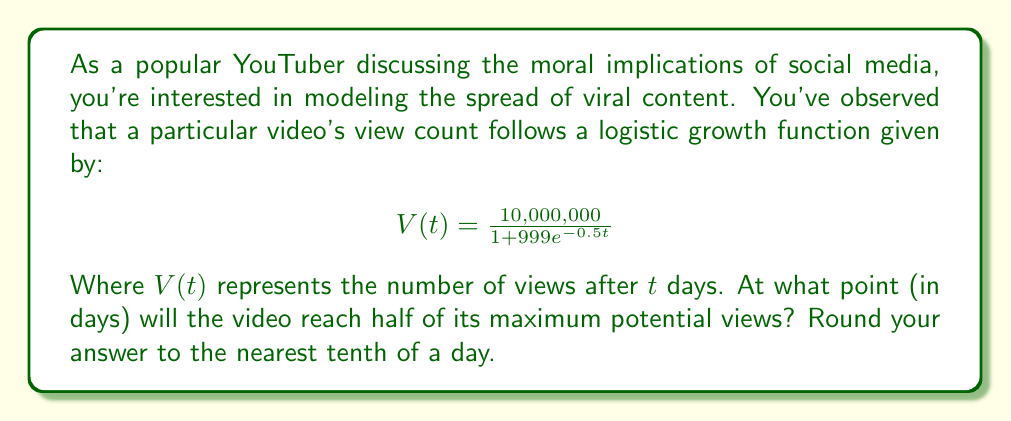Give your solution to this math problem. To solve this problem, we'll follow these steps:

1) First, identify the maximum potential views (carrying capacity) from the logistic function:
   The carrying capacity is the numerator, which is 10,000,000 views.

2) Calculate half of the maximum views:
   $\frac{10,000,000}{2} = 5,000,000$ views

3) Set up the equation:
   $$5,000,000 = \frac{10,000,000}{1 + 999e^{-0.5t}}$$

4) Simplify:
   $$\frac{1}{2} = \frac{1}{1 + 999e^{-0.5t}}$$

5) Take the reciprocal of both sides:
   $$2 = 1 + 999e^{-0.5t}$$

6) Subtract 1 from both sides:
   $$1 = 999e^{-0.5t}$$

7) Divide both sides by 999:
   $$\frac{1}{999} = e^{-0.5t}$$

8) Take the natural log of both sides:
   $$\ln(\frac{1}{999}) = -0.5t$$

9) Divide both sides by -0.5:
   $$\frac{\ln(\frac{1}{999})}{-0.5} = t$$

10) Calculate:
    $$t = \frac{\ln(999)}{0.5} \approx 13.82$$

11) Round to the nearest tenth:
    $t \approx 13.8$ days
Answer: 13.8 days 